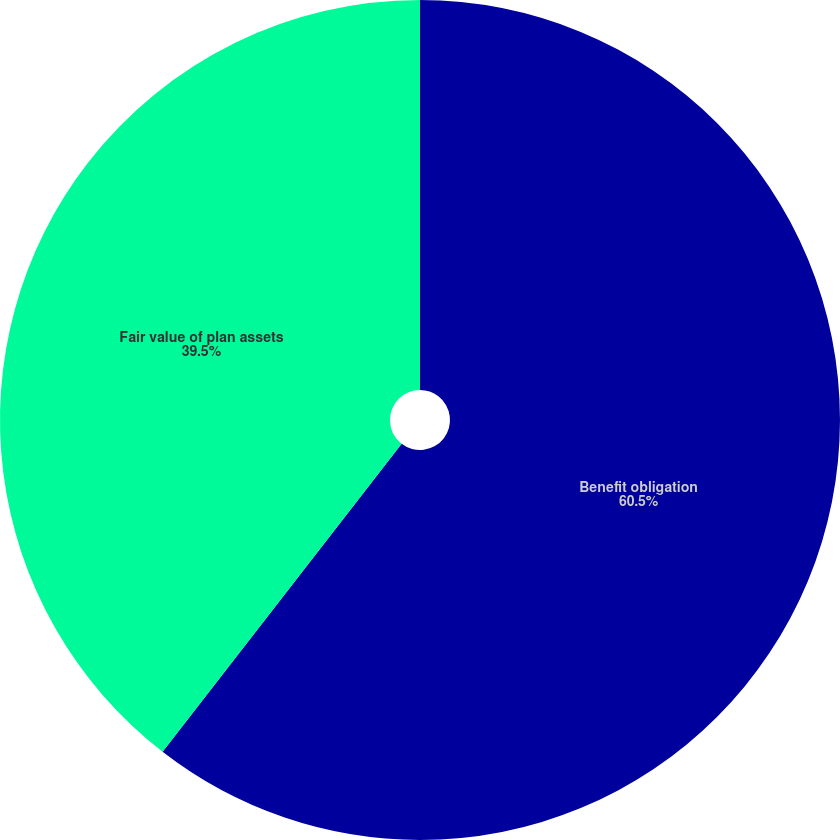<chart> <loc_0><loc_0><loc_500><loc_500><pie_chart><fcel>Benefit obligation<fcel>Fair value of plan assets<nl><fcel>60.5%<fcel>39.5%<nl></chart> 